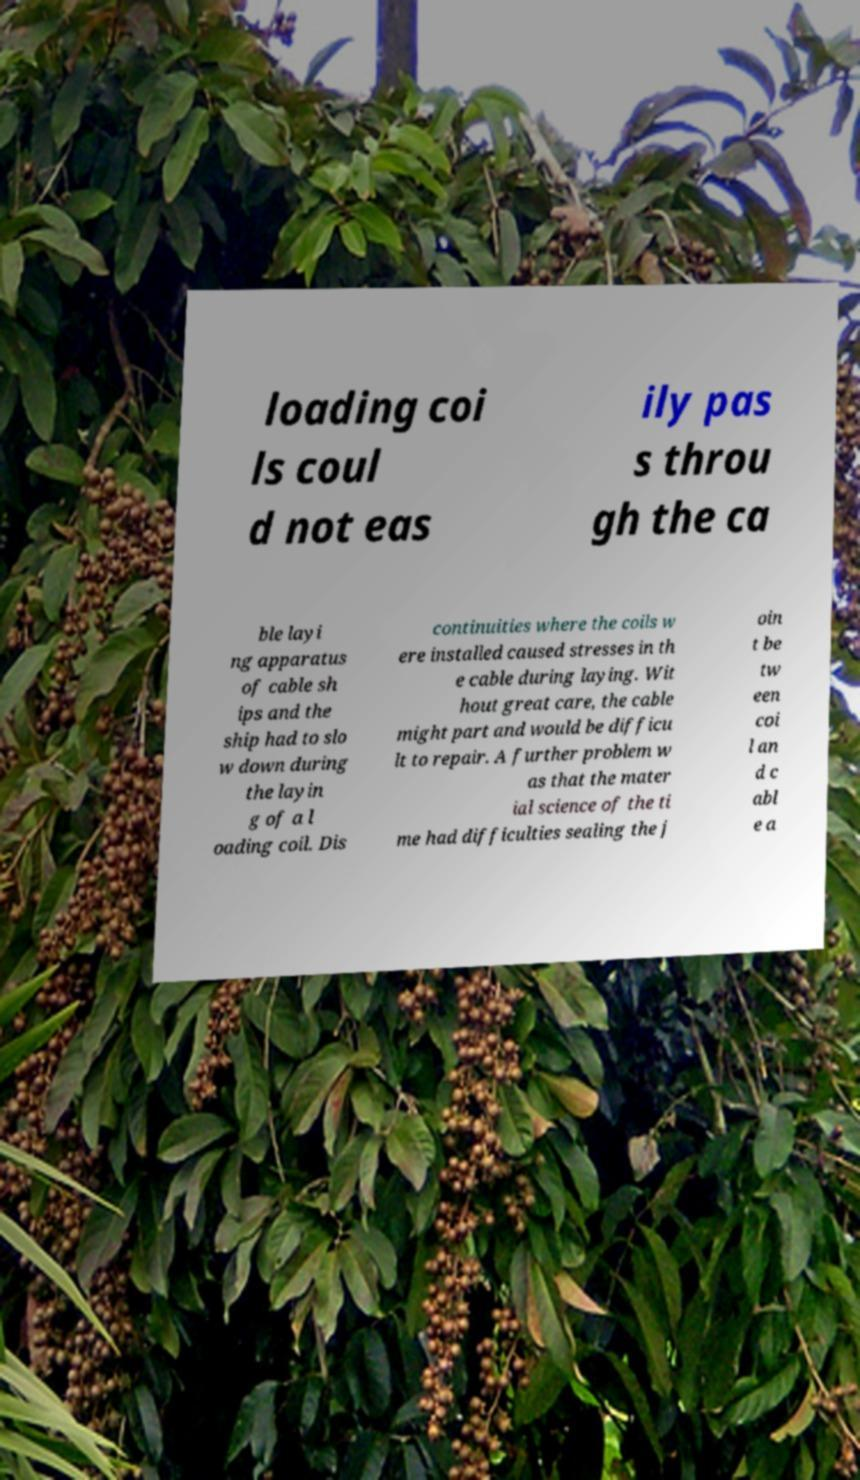Could you extract and type out the text from this image? loading coi ls coul d not eas ily pas s throu gh the ca ble layi ng apparatus of cable sh ips and the ship had to slo w down during the layin g of a l oading coil. Dis continuities where the coils w ere installed caused stresses in th e cable during laying. Wit hout great care, the cable might part and would be difficu lt to repair. A further problem w as that the mater ial science of the ti me had difficulties sealing the j oin t be tw een coi l an d c abl e a 